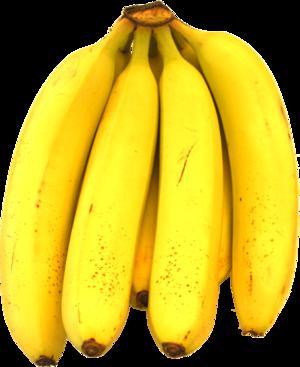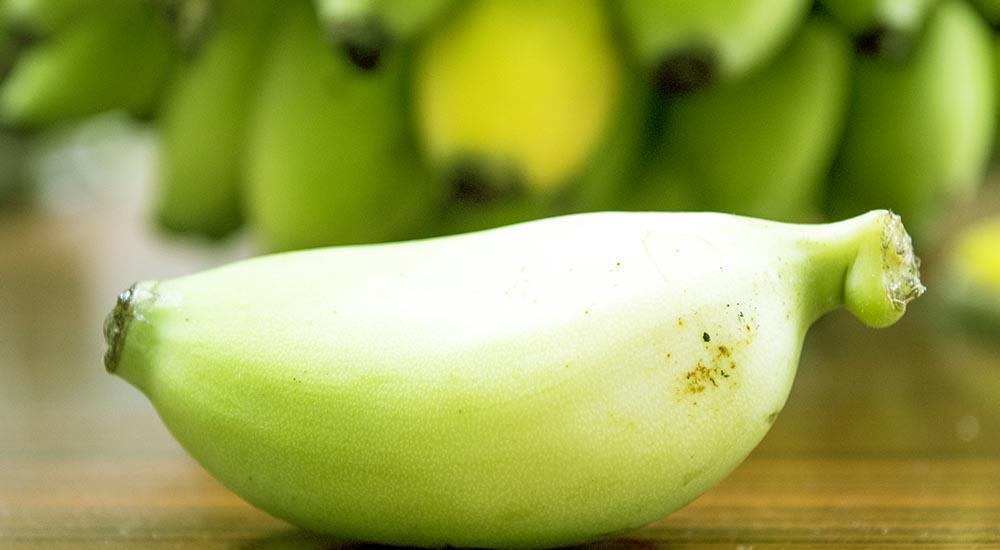The first image is the image on the left, the second image is the image on the right. Analyze the images presented: Is the assertion "One image shows a beverage in a clear glass in front of joined bananas, and the other image contains only yellow bananas in a bunch." valid? Answer yes or no. No. The first image is the image on the left, the second image is the image on the right. Evaluate the accuracy of this statement regarding the images: "A glass sits near a few bananas in one of the images.". Is it true? Answer yes or no. No. 